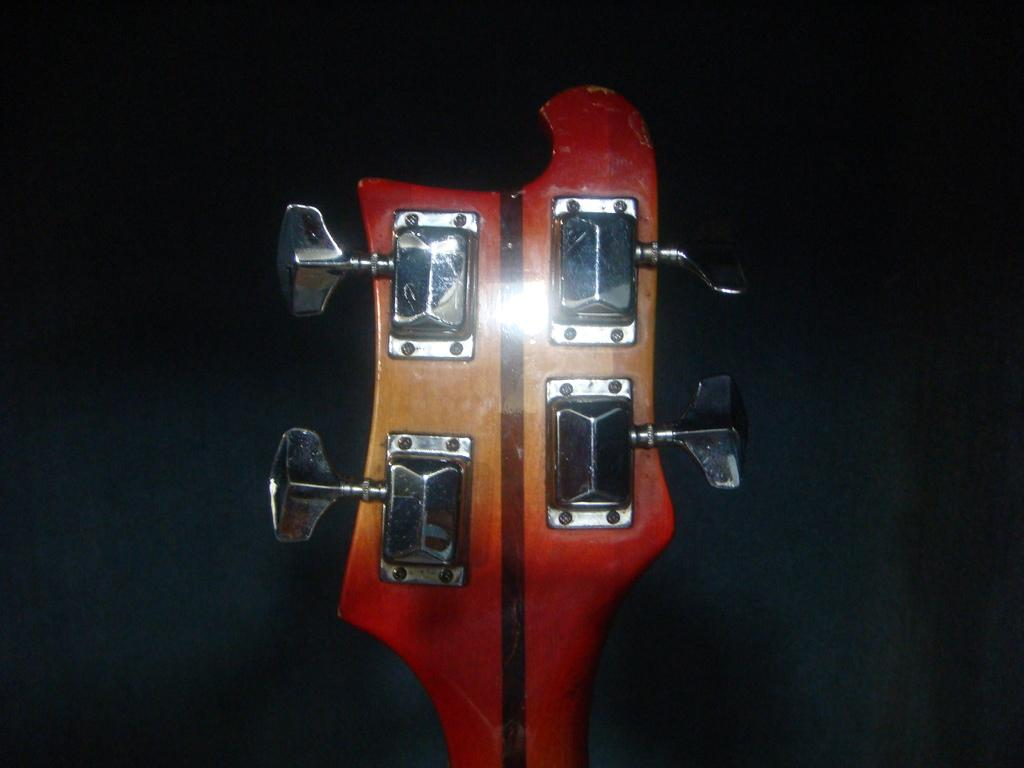What is the primary material used in the object in the image? The primary material used in the object in the image is red color wooden material. How many screws are visible on the wooden material? The wooden material has four screws. What is the object in the image likely used for? The wooden material is likely a guitar. What is the color of the background in the image? The background of the image is dark. Can you see any pigs playing in the harbor in the image? There is no harbor or pigs present in the image; it features a wooden material that is likely a guitar. 